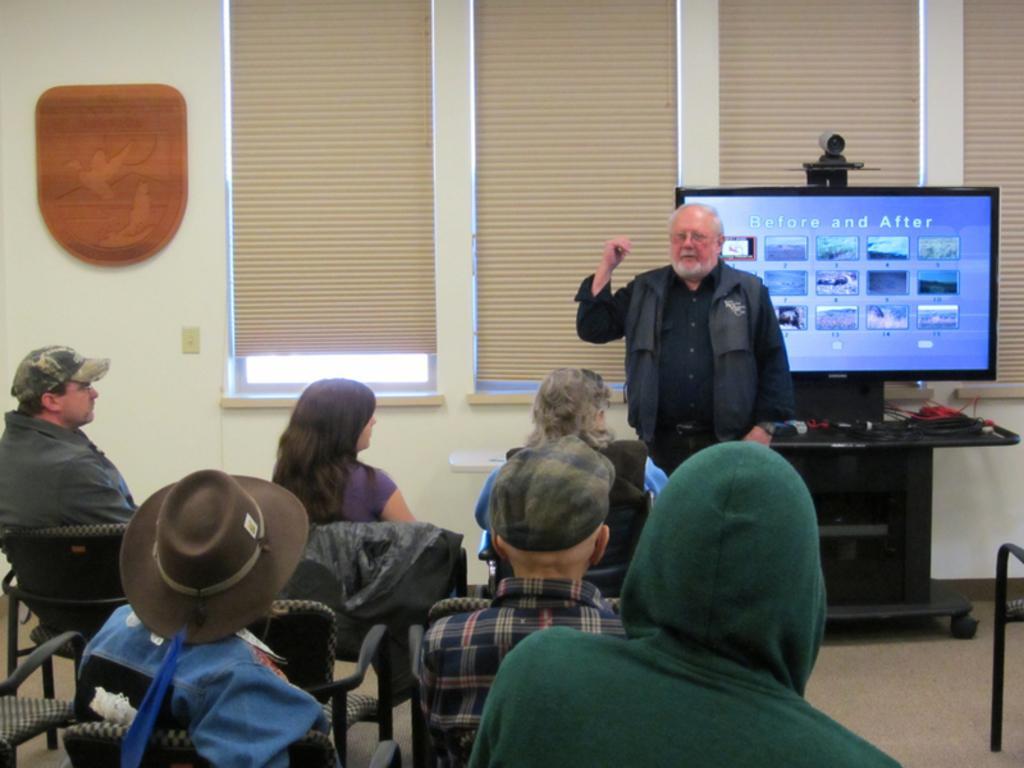Describe this image in one or two sentences. In this picture I can see a person standing and pointing his fingers towards the monitor which is on the desk. There are people sitting in front of the monitor and there is a wall and some object on it. Also there are windows and curtains. 